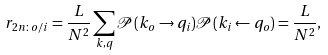<formula> <loc_0><loc_0><loc_500><loc_500>r _ { 2 n \colon o / i } = \frac { L } { N ^ { 2 } } \sum _ { k , q } \mathcal { P } ( k _ { o } \to q _ { i } ) \mathcal { P } ( k _ { i } \gets q _ { o } ) = \frac { L } { N ^ { 2 } } ,</formula> 